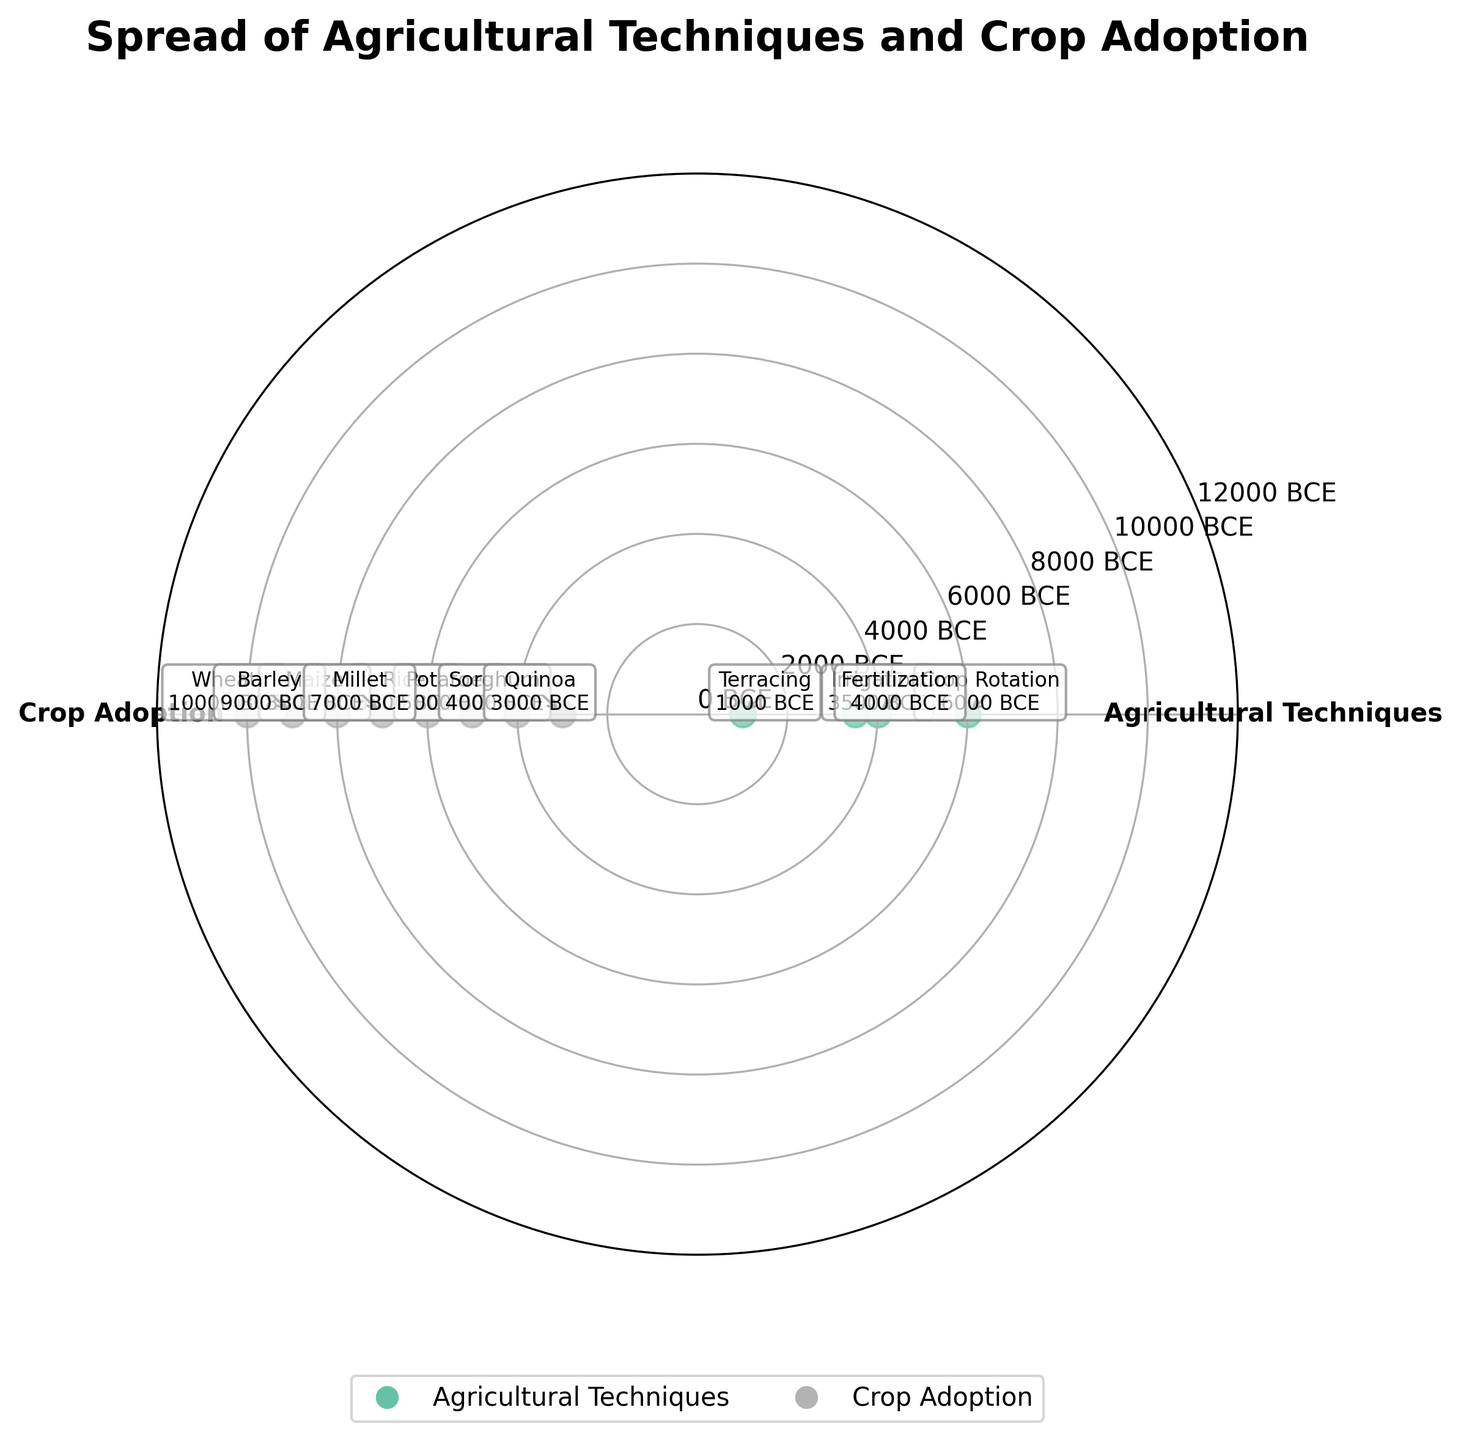What is the title of the chart? The title can be seen at the top of the chart.
Answer: Spread of Agricultural Techniques and Crop Adoption How many main categories are depicted in the chart? There are distinct colored segments, each representing a unique main category, indicated by different colors and labels on the radial axis.
Answer: 2 Around which category do the data points for 'Wheat' cluster? Look for data points labeled 'Wheat' and identify the main category they are associated with.
Answer: Crop Adoption Which technique was adopted earliest and which crop was adopted earliest? Identify the data points with the smallest numeric values in each category. Crop Rotation corresponds to 6000 BCE among techniques and Wheat corresponds to 10000 BCE among crops.
Answer: Crop Rotation and Wheat What is the approximate time difference between the adoption of 'Irrigation' and 'Terracing'? Find the numeric values corresponding to Irrigation (3500 BCE) and Terracing (1000 BCE) and compute the difference. 3500 BCE - 1000 BCE = 2500 years.
Answer: 2500 years Which crop was adopted most recently? Identify the crop with the largest numeric value on the radial scale.
Answer: Quinoa Which agricultural technique was adopted most recently? Among the agricultural techniques, identify the one with the latest (largest numeric value) adoption year.
Answer: Terracing Arrange the crops 'Rice', 'Potatoes', and 'Barley' in the order of their adoption. Compare the numeric values for each crop and arrange based on the values (smallest to largest).
Answer: Barley, Rice, Potatoes Is 'Fertilization' older or younger than 'Sorghum'? Compare the numeric values associated with Fertilization (4000 BCE) and Sorghum (4000 BCE) in the context of their categories.
Answer: Same age What's the difference in years between the adoption of 'Millet' and 'Maize'? Identify the numeric values for Millet (7000 BCE) and Maize (8000 BCE) and compute the difference. 8000 BCE - 7000 BCE = 1000 years.
Answer: 1000 years 